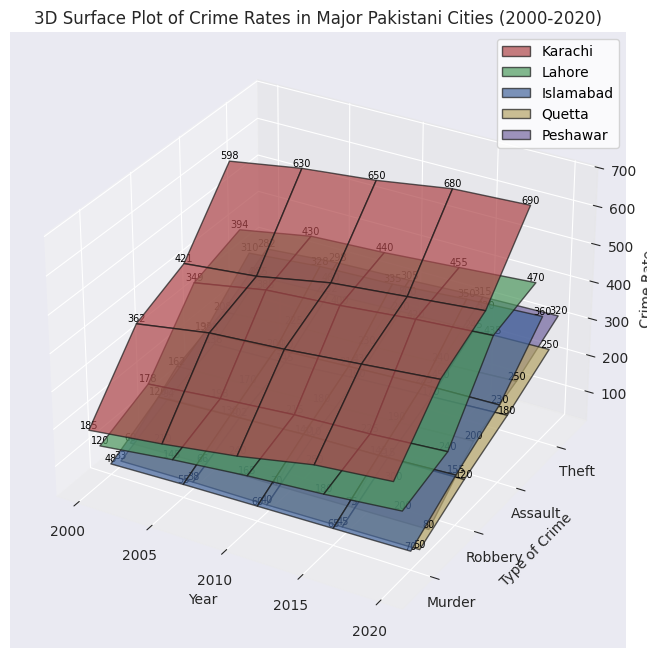Which city showed the highest murder rates in 2020? Looking at the height of the bars corresponding to murder rates in different cities for the year 2020, we see that Karachi has the highest value.
Answer: Karachi Comparing Lahore and Islamabad, which city had higher robbery rates in 2015? By comparing the heights of the bars corresponding to robbery rates for the year 2015 in both Lahore and Islamabad, Lahore’s bar is taller, indicating a higher robbery rate.
Answer: Lahore What is the overall trend for assault rates in Karachi from 2000 to 2020? Observing the surface for assault rates in Karachi over the years from 2000 to 2020, the heights of the bars increase, showing a rising trend.
Answer: Rising Which crime type in Quetta showed the least change from 2000 to 2020? Analyzing the surface for Quetta, the horizontal bars for ‘Theft’ show relatively consistent heights over the years compared to other crimes that fluctuate more.
Answer: Theft Is robbery in Peshawar higher in 2010 compared to 2000? The height of the robbery bar in Peshawar for 2010 can be visually compared to that for 2000. The higher bar in 2010 indicates an increase.
Answer: Yes Between Lahore and Karachi, which city had a higher increase in murder rates from 2000 to 2020? Calculate the increase in murder rates for both cities: For Karachi, it’s 300 (2020) - 185 (2000) = 115. For Lahore, it’s 200 (2020) - 120 (2000) = 80. Karachi has a higher increase.
Answer: Karachi Which year shows the lowest theft rate in Islamabad? The height of the theft bars in Islamabad across different years shows the lowest point in the year 2000.
Answer: 2000 How do the assault rates in Quetta in 2015 compare to those in Peshawar in the same year? Comparing the heights of the bars for assault rates in Quetta and Peshawar in 2015, Peshawar has taller bars indicating higher rates.
Answer: Peshawar Among the five cities, which one exhibited the least change in murder rates between 2000 and 2020? Calculating the differences between murder rates from 2000 to 2020 for each city, Quetta shows the smallest difference: 50 (2020) - 33 (2000) = 17.
Answer: Quetta 